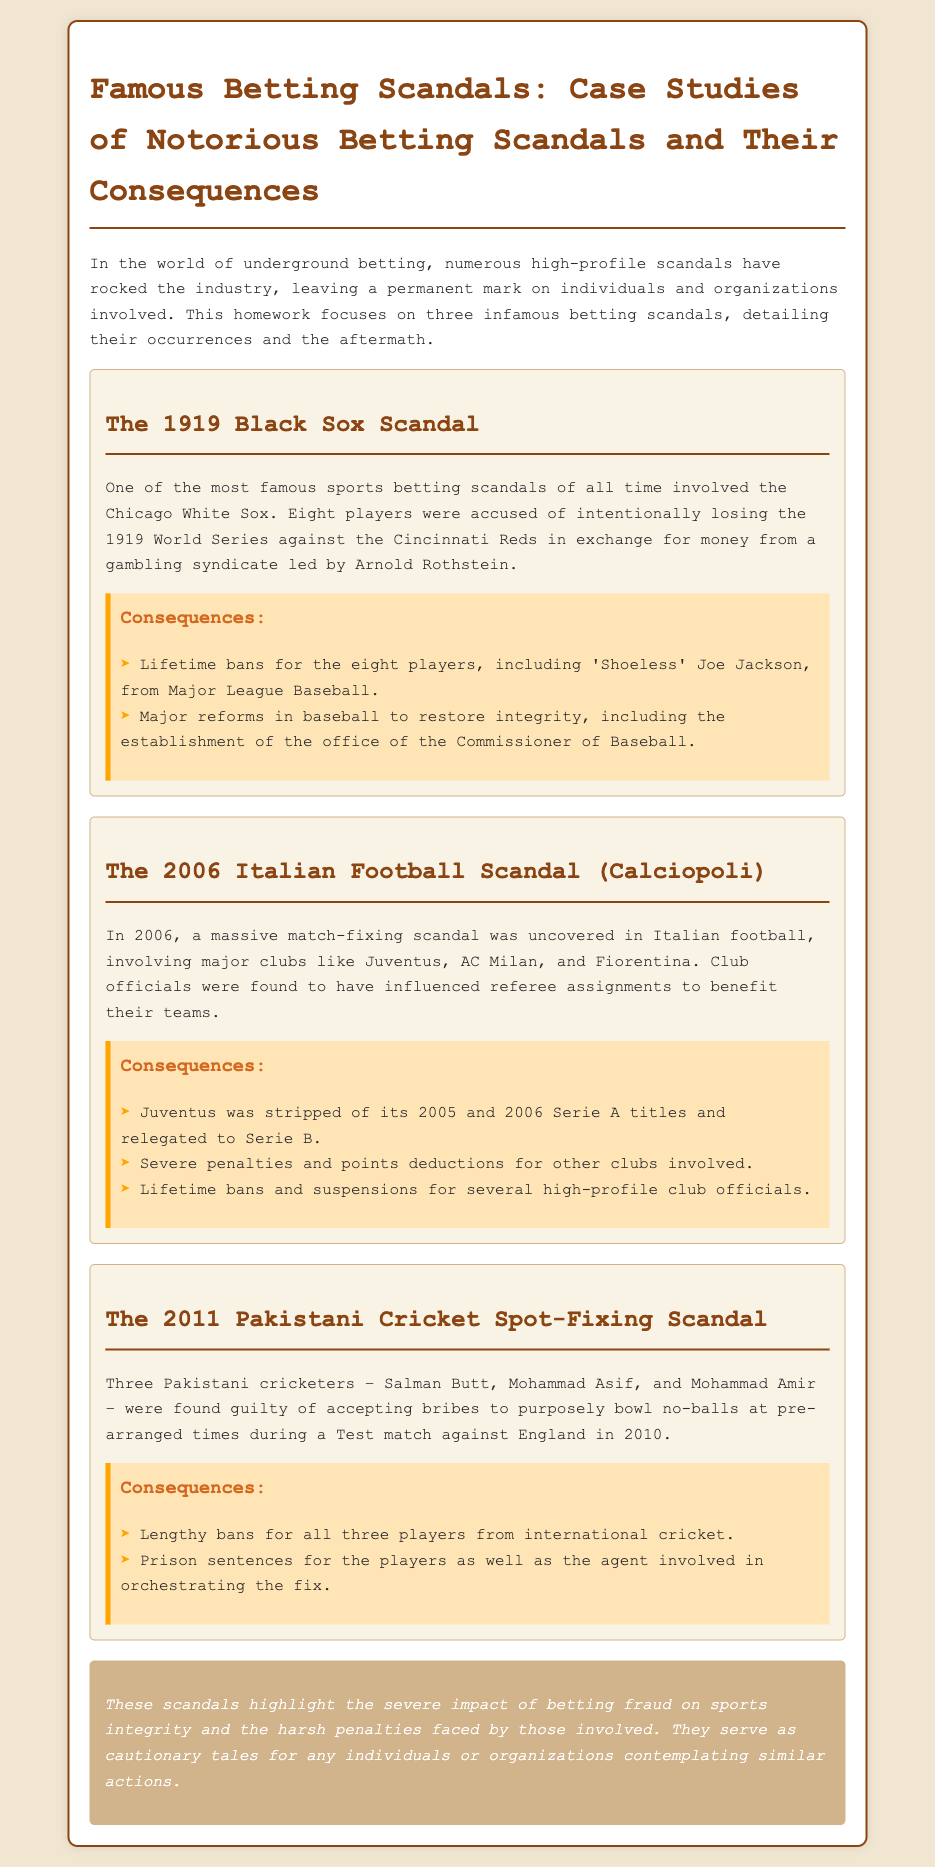What scandal occurred in 1919? The document states that the 1919 scandal involved the Chicago White Sox, who were accused of intentionally losing the World Series.
Answer: Black Sox Scandal Who was the gambling syndicate leader in the 1919 scandal? The text mentions Arnold Rothstein as the leader of the gambling syndicate involved in the Black Sox Scandal.
Answer: Arnold Rothstein Which team was stripped of its Serie A titles due to the 2006 scandal? The consequences section of the Italian Football Scandal states that Juventus was stripped of its titles for 2005 and 2006.
Answer: Juventus How many Pakistani cricketers were involved in the 2011 spot-fixing scandal? The document lists three Pakistani cricketers who were found guilty in the spot-fixing scandal.
Answer: Three What was a major consequence for the eight White Sox players? The document notes that all eight players received lifetime bans from Major League Baseball as a consequence of the scandal.
Answer: Lifetime bans What significant reform happened in Major League Baseball after the Black Sox Scandal? The document mentions that major reforms were made in baseball, notably the establishment of the Commissioner's office.
Answer: Office of the Commissioner of Baseball Which two clubs were among those involved in the 2006 Italian Football Scandal? The text lists Juventus and AC Milan as clubs implicated in the scandal.
Answer: Juventus, AC Milan What year did the spot-fixing scandal occur? The document states that the spot-fixing incident took place during a Test match in 2010.
Answer: 2010 